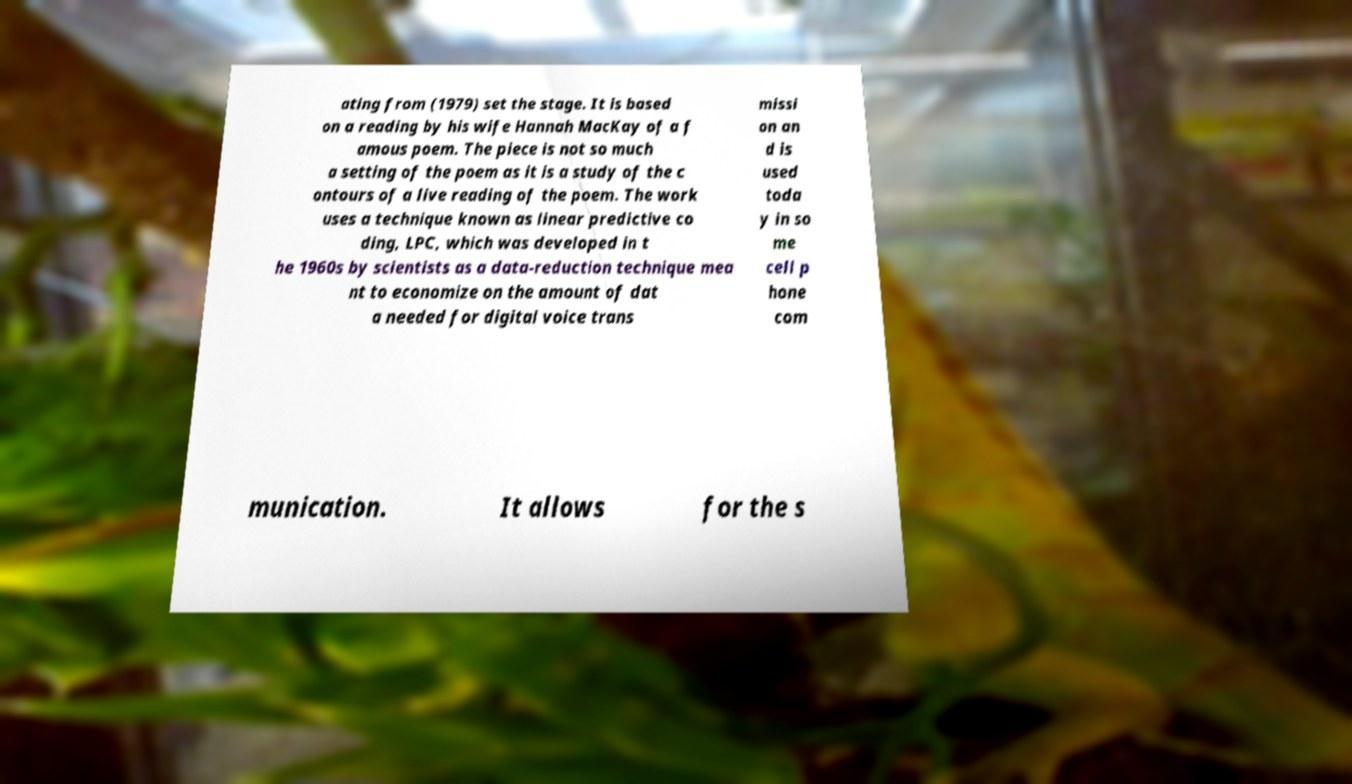Could you extract and type out the text from this image? ating from (1979) set the stage. It is based on a reading by his wife Hannah MacKay of a f amous poem. The piece is not so much a setting of the poem as it is a study of the c ontours of a live reading of the poem. The work uses a technique known as linear predictive co ding, LPC, which was developed in t he 1960s by scientists as a data-reduction technique mea nt to economize on the amount of dat a needed for digital voice trans missi on an d is used toda y in so me cell p hone com munication. It allows for the s 